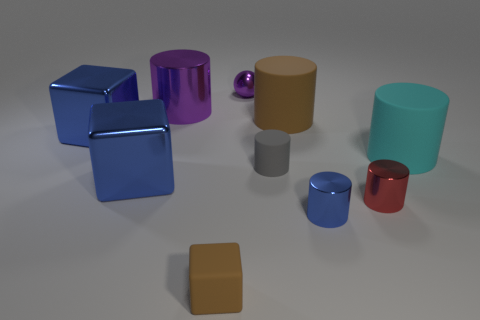Subtract all matte blocks. How many blocks are left? 2 Subtract all purple cylinders. How many cylinders are left? 5 Subtract 1 spheres. How many spheres are left? 0 Subtract all purple cubes. Subtract all yellow cylinders. How many cubes are left? 3 Subtract all blue balls. How many gray cylinders are left? 1 Subtract all big gray metallic cylinders. Subtract all matte cylinders. How many objects are left? 7 Add 8 tiny gray objects. How many tiny gray objects are left? 9 Add 1 small objects. How many small objects exist? 6 Subtract 0 red cubes. How many objects are left? 10 Subtract all blocks. How many objects are left? 7 